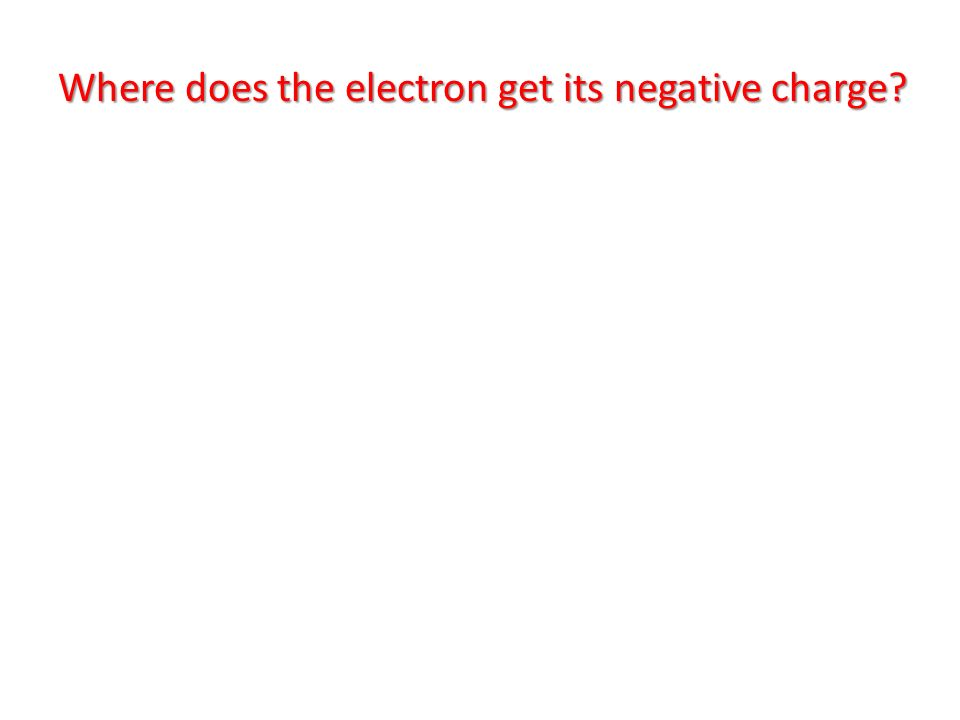Could the color choice for the background and text signify any particular importance or urgency related to the question presented? Based solely on the image provided, the stark contrast between the red background and the white text can be interpreted as a method to draw attention. Red is a color often associated with importance, urgency, and caution. For example, it is commonly used to indicate warnings or critical information. The use of white text on a red background enhances readability and focus, ensuring that the message is easily noticed and read quickly. This color choice likely signifies that the question posed is of considerable importance, possibly highlighting its significance in a scientific, educational, or safety context. However, without additional context, this interpretation remains speculative and is based on common associations with the color red in graphic design. 